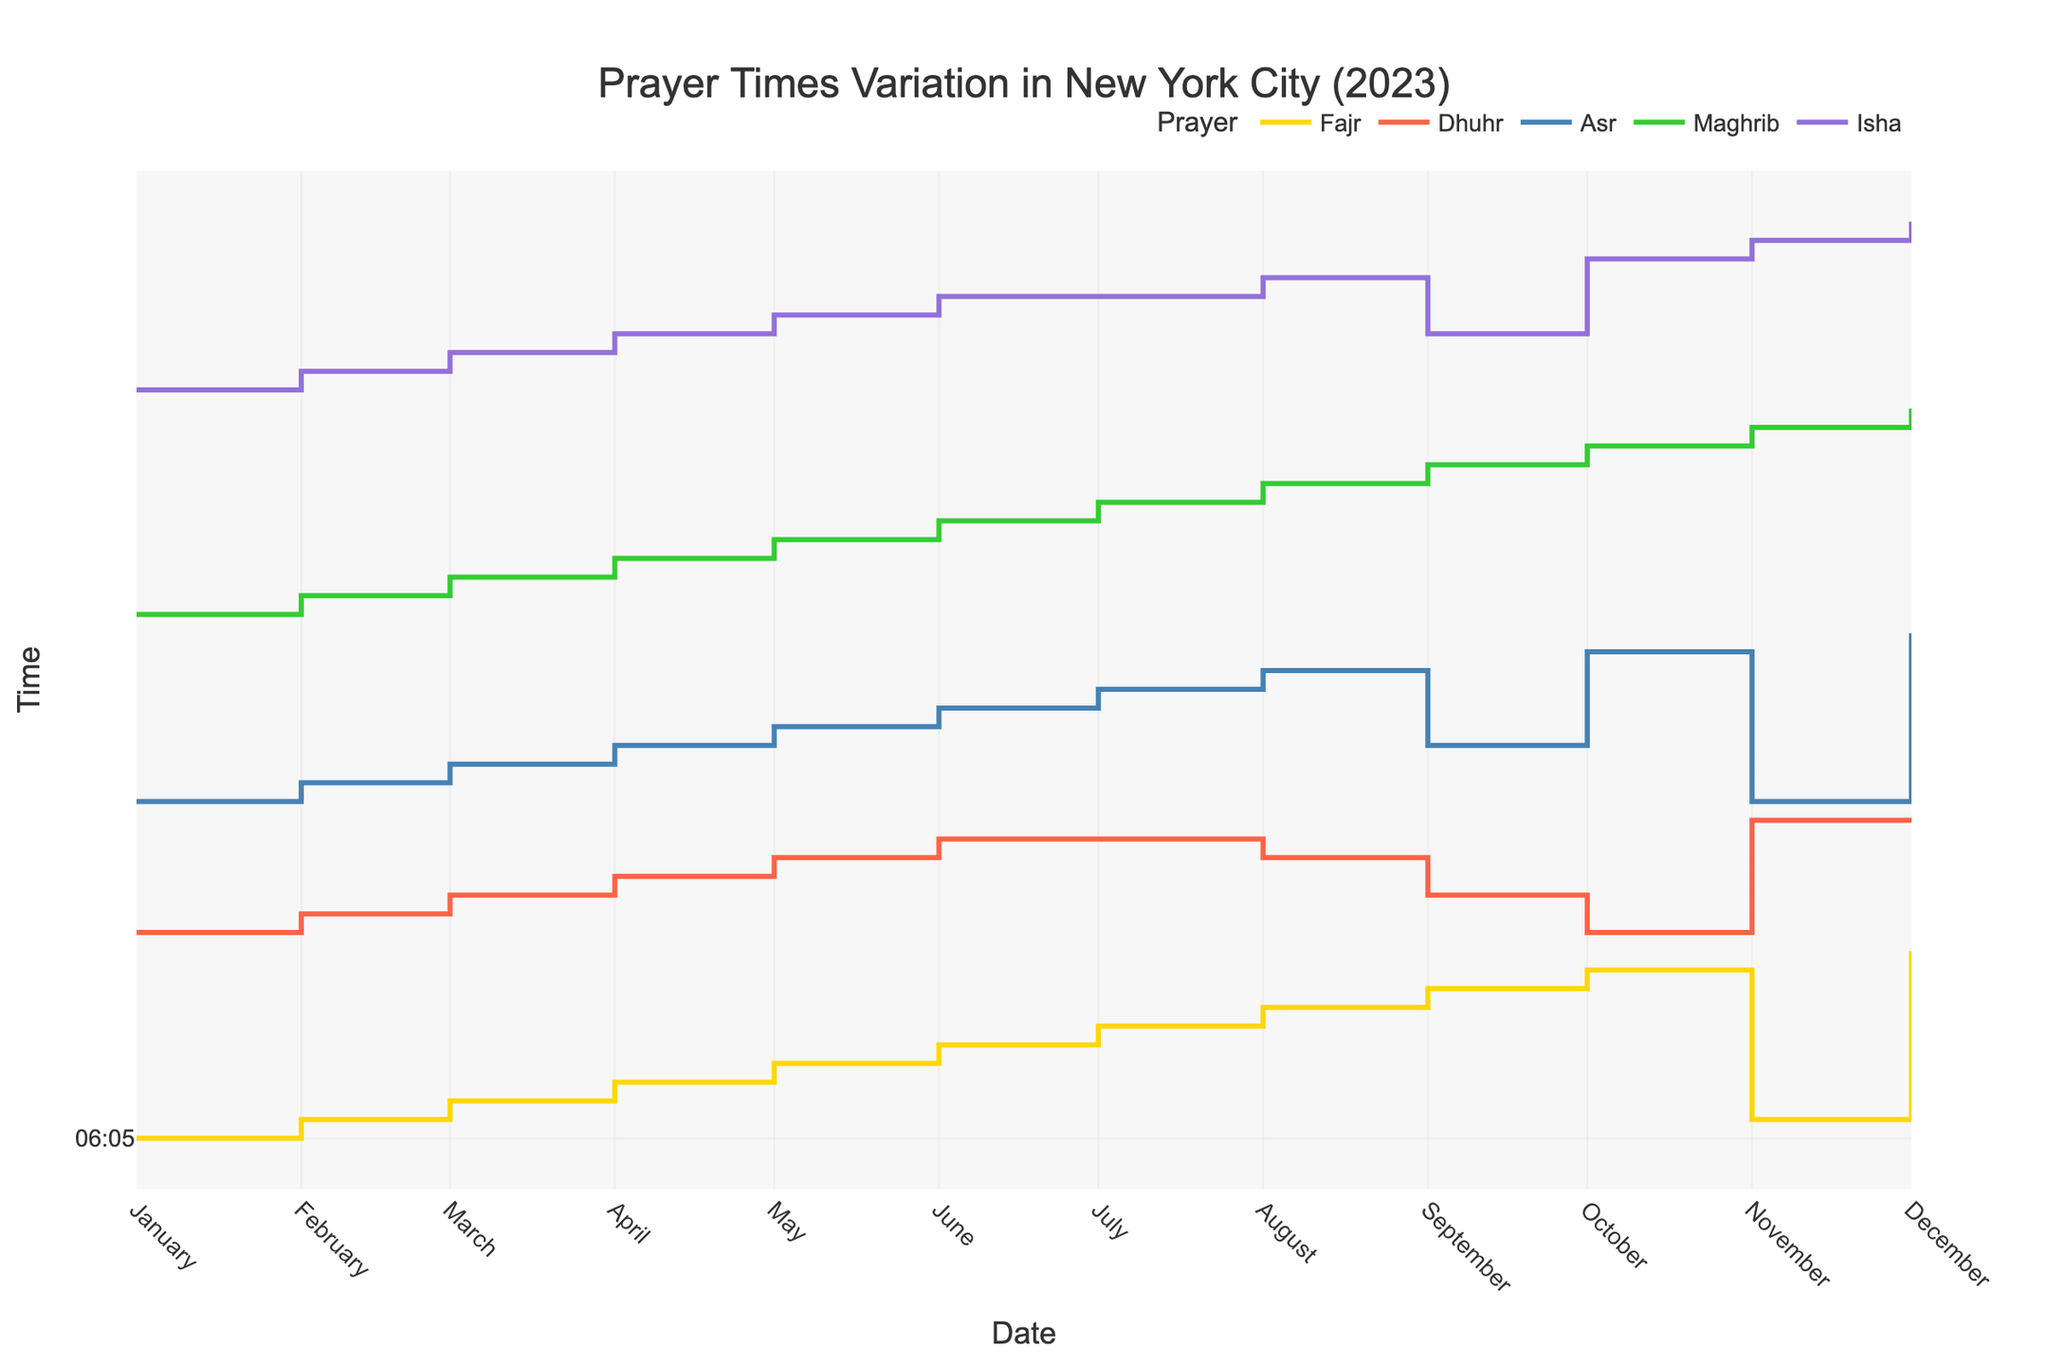How many prayer times are plotted in the figure? The figure plots five different prayer times as indicated by the lines labeled Fajr, Dhuhr, Asr, Maghrib, and Isha in the legend.
Answer: Five What is the title of the figure? The title of the figure is prominently displayed at the top center and reads "Prayer Times Variation in New York City (2023)".
Answer: Prayer Times Variation in New York City (2023) Which prayer time is the earliest during the year 2023? By examining the y-axis and the lines for each prayer time, the Fajr prayer (yellow line) starts earliest each day throughout the year.
Answer: Fajr Are there any months where the Isha prayer time stays constant? The Isha prayer time (purple line) shows no significant variation in July when it is constant at around 20:36.
Answer: July Which prayer time shows the most significant variation throughout the year? By looking at the steepness and span of the lines, the Fajr prayer (yellow line) shows the most significant variation, ranging from 03:59 to 06:07.
Answer: Fajr What is the range of the Maghrib prayer time across the whole year? The Maghrib prayer time (green line) starts at around 16:10 in November and goes up to approximately 18:56 in July. The range is calculated as 18:56 - 16:10.
Answer: Approximately 2 hours and 46 minutes During which month is the Fajr prayer time the latest? By examining the Fajr prayer time line (yellow), the latest time is in December, around 06:07.
Answer: December Between the Dhuhr and Asr prayer times, which shows more variation across the year? Comparing the blue line (Dhuhr) and red line (Asr), the Asr prayer time shifts more significantly from 14:50 to 17:10.
Answer: Asr What is the Maghrib prayer time on July 1st? Hovering over the green line on July 1, you see the Maghrib prayer time is around 18:56.
Answer: 18:56 How does the Fajr prayer time in June compare with that in March? The Fajr prayer time in June (03:59) is earlier than in March (05:18).
Answer: Earlier 